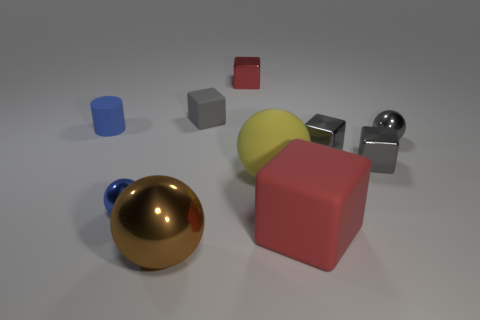Subtract all gray cubes. How many were subtracted if there are1gray cubes left? 2 Subtract all big rubber balls. How many balls are left? 3 Subtract all green cylinders. How many gray blocks are left? 3 Subtract 2 balls. How many balls are left? 2 Subtract all gray spheres. How many spheres are left? 3 Subtract all balls. How many objects are left? 6 Add 2 large purple shiny cylinders. How many large purple shiny cylinders exist? 2 Subtract 0 green blocks. How many objects are left? 10 Subtract all cyan spheres. Subtract all yellow cylinders. How many spheres are left? 4 Subtract all balls. Subtract all small metallic balls. How many objects are left? 4 